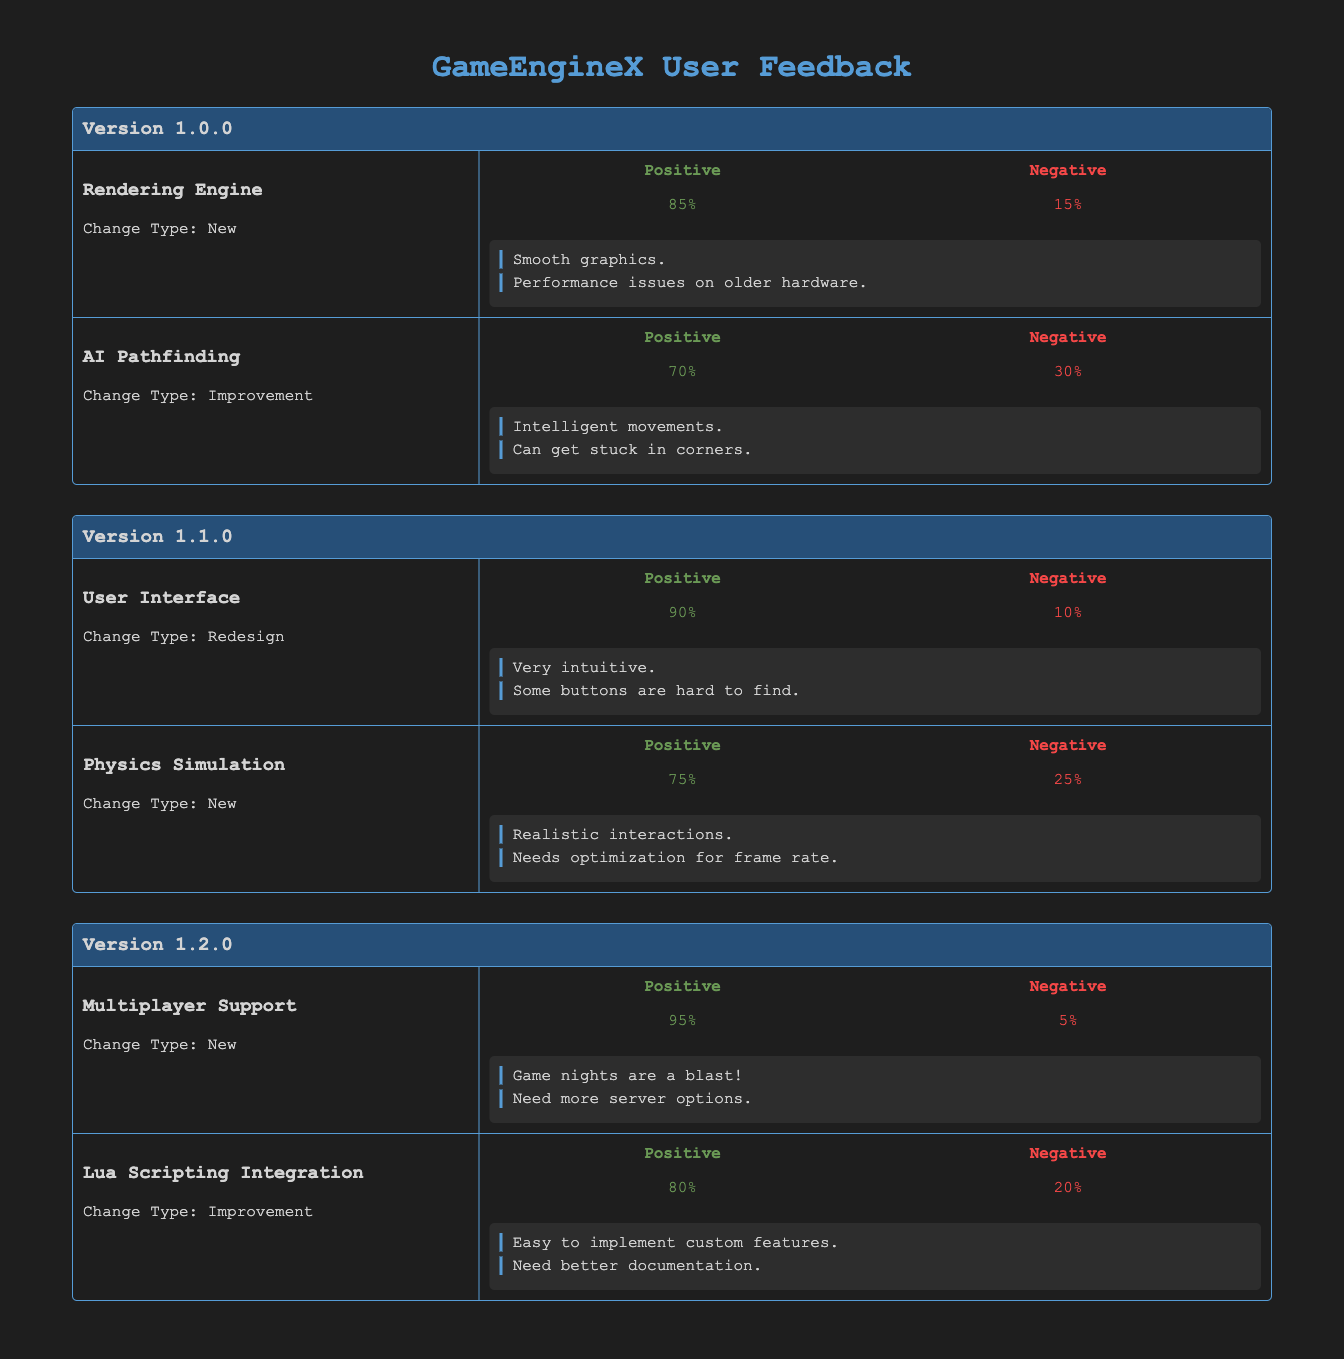What is the positive feedback percentage for the "Rendering Engine" feature in version 1.0.0? The "Rendering Engine" feature in version 1.0.0 has 85% positive feedback as indicated in the corresponding row of the table.
Answer: 85% What change type was applied to the "User Interface" feature in version 1.1.0? The change type for the "User Interface" feature in version 1.1.0 is "Redesign", which is explicitly mentioned in the table.
Answer: Redesign Which feature received the lowest percentage of positive feedback in all versions? To find the lowest percentage of positive feedback, we can compare the values: Rendering Engine (85%), AI Pathfinding (70%), User Interface (90%), Physics Simulation (75%), Multiplayer Support (95%), Lua Scripting Integration (80%). The feature with the lowest percentage is "AI Pathfinding" at 70%.
Answer: AI Pathfinding Is the percentage of negative feedback for the "Multiplayer Support" feature greater than that for the "Physics Simulation"? The "Multiplayer Support" feature has 5% negative feedback, while the "Physics Simulation" feature has 25%. Since 5% is not greater than 25%, the answer is no.
Answer: No What is the average positive feedback percentage across all features in version 1.2.0? The positive feedback percentages in version 1.2.0 are: Multiplayer Support (95%) and Lua Scripting Integration (80%). The average is calculated as (95 + 80) / 2 = 87.5%.
Answer: 87.5% Which feature's user feedback comments mention the need for better documentation? The feature "Lua Scripting Integration" has comments that mention the need for better documentation, as indicated in its feedback information.
Answer: Lua Scripting Integration What is the difference in negative feedback percentage between the "AI Pathfinding" and "User Interface" features? The "AI Pathfinding" feature has 30% negative feedback, while the "User Interface" has 10%. The difference is calculated as 30% - 10% = 20%.
Answer: 20% How many features in version 1.1.0 have positive feedback percentages above 70%? In version 1.1.0, the features are: User Interface (90%) and Physics Simulation (75%). Both have positive feedback percentages above 70%, making a total of 2 features.
Answer: 2 What percentage of users provided negative feedback for the "Physics Simulation" feature? The "Physics Simulation" feature received 25% negative feedback, which is stated in the feedback section of the table.
Answer: 25% 